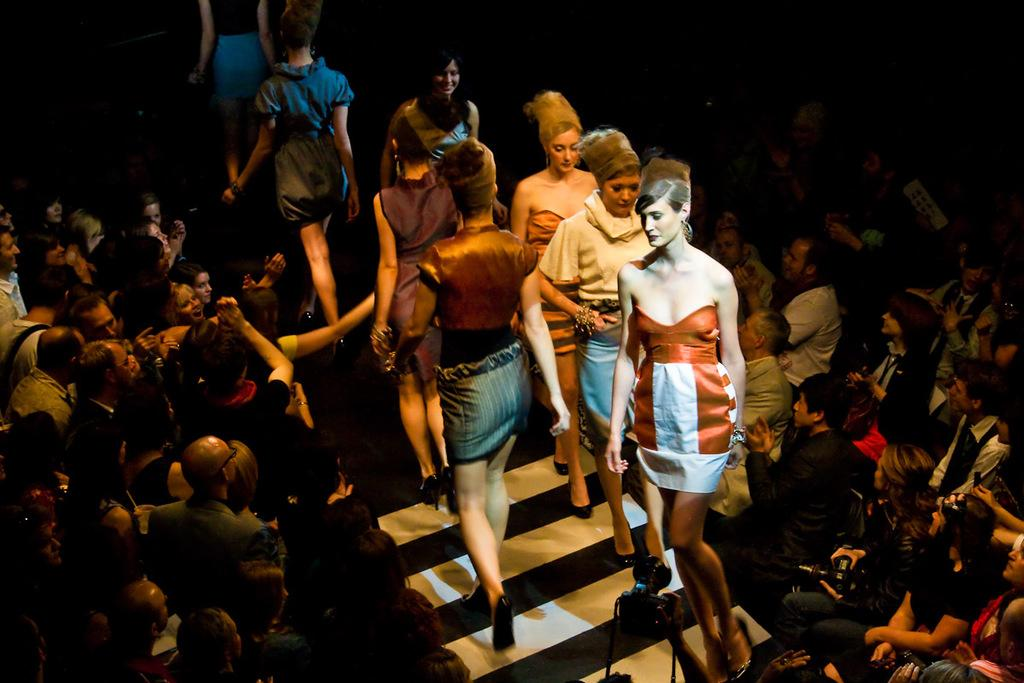What are the ladies in the image doing? The ladies are walking on a ramp in the image. Are there any other people present in the image besides the ladies? Yes, there are people sitting on chairs on either side of the ramp. What type of drum can be seen being played by the ladies in the image? There is no drum present in the image; the ladies are walking on a ramp. 